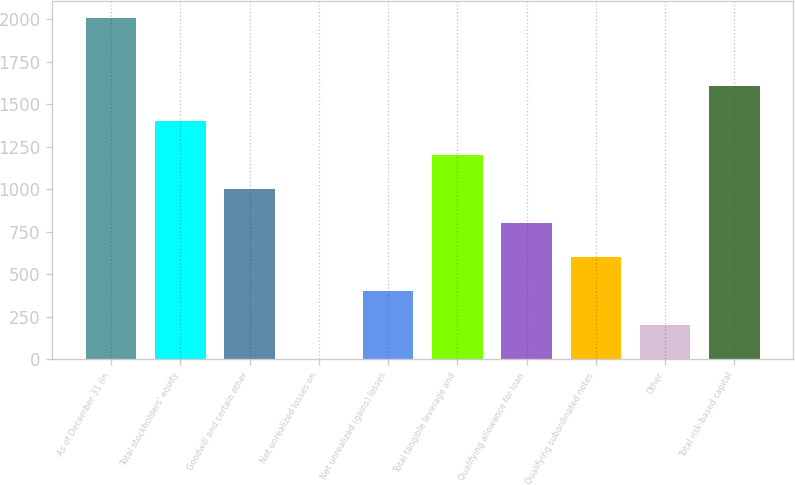Convert chart. <chart><loc_0><loc_0><loc_500><loc_500><bar_chart><fcel>As of December 31 (in<fcel>Total stockholders' equity<fcel>Goodwill and certain other<fcel>Net unrealized losses on<fcel>Net unrealized (gains) losses<fcel>Total tangible leverage and<fcel>Qualifying allowance for loan<fcel>Qualifying subordinated notes<fcel>Other<fcel>Total risk-based capital<nl><fcel>2005<fcel>1403.53<fcel>1002.55<fcel>0.1<fcel>401.08<fcel>1203.04<fcel>802.06<fcel>601.57<fcel>200.59<fcel>1604.02<nl></chart> 